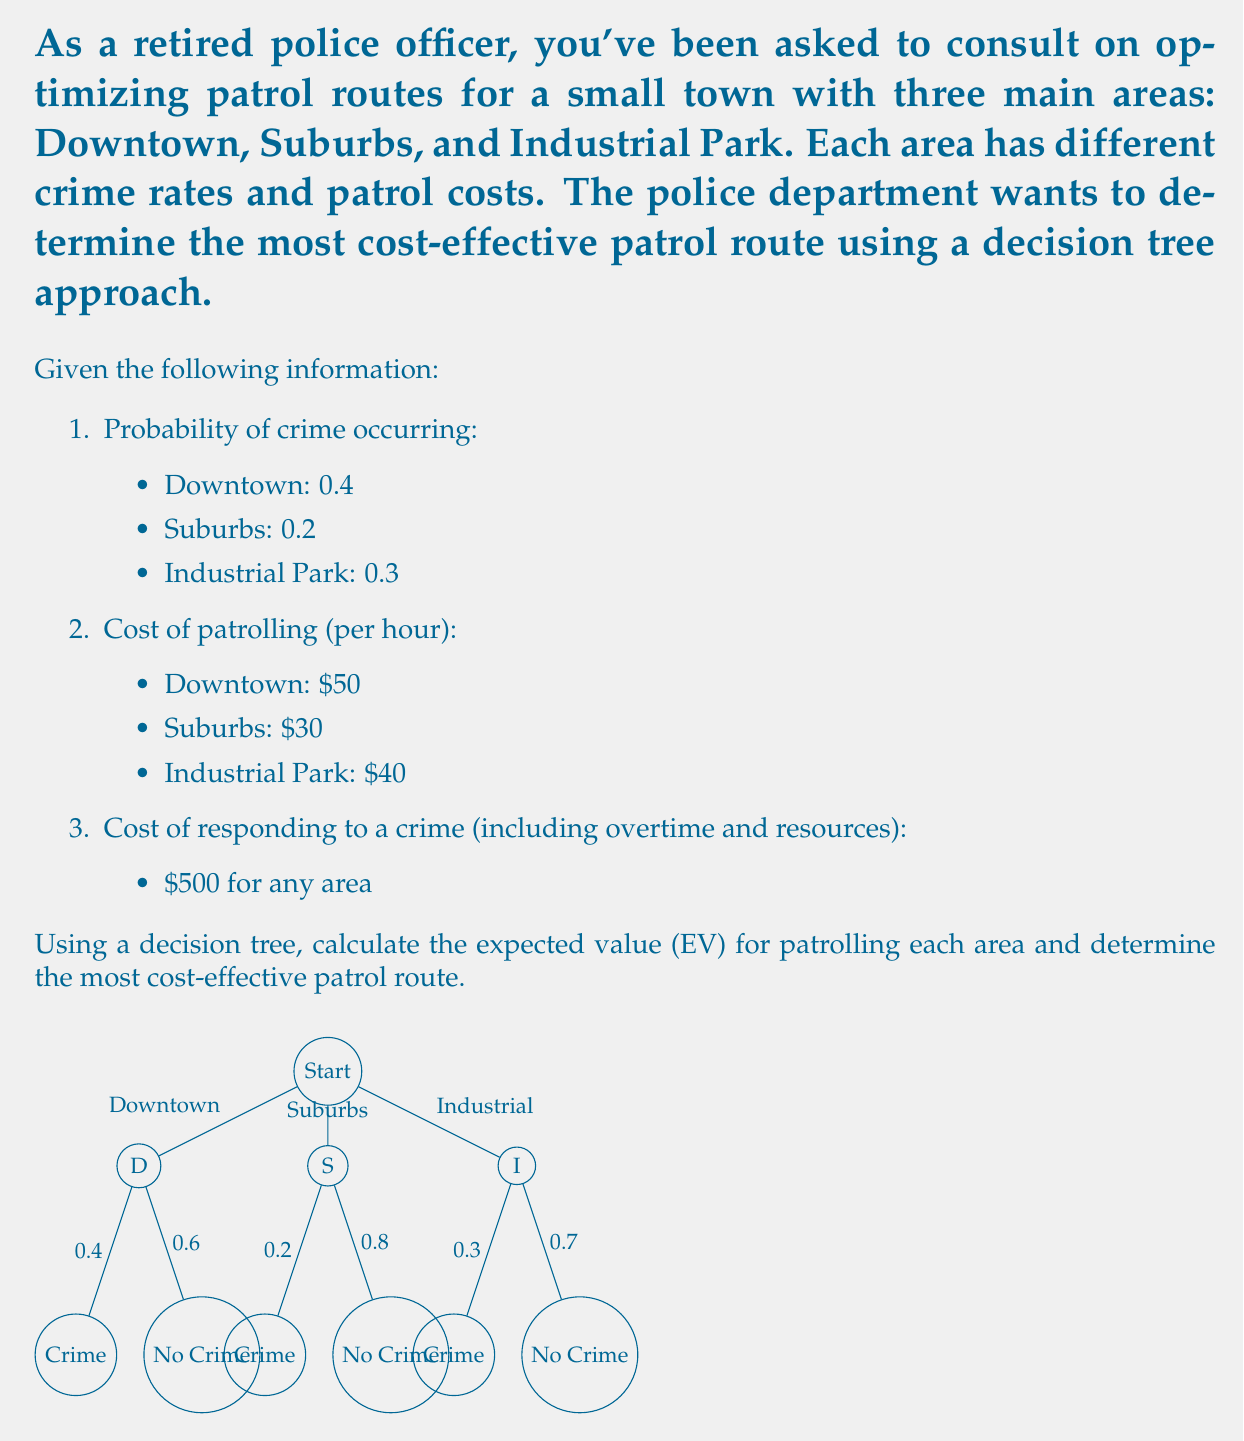Could you help me with this problem? Let's solve this problem step-by-step using decision tree analysis and expected value calculations:

1. Calculate the expected value for patrolling Downtown:
   - Probability of crime: 0.4
   - Probability of no crime: 1 - 0.4 = 0.6
   - Cost if crime occurs: $50 (patrol) + $500 (response) = $550
   - Cost if no crime occurs: $50 (patrol only)
   
   $EV_{Downtown} = 0.4 \times 550 + 0.6 \times 50 = 220 + 30 = $250$

2. Calculate the expected value for patrolling Suburbs:
   - Probability of crime: 0.2
   - Probability of no crime: 1 - 0.2 = 0.8
   - Cost if crime occurs: $30 (patrol) + $500 (response) = $530
   - Cost if no crime occurs: $30 (patrol only)
   
   $EV_{Suburbs} = 0.2 \times 530 + 0.8 \times 30 = 106 + 24 = $130$

3. Calculate the expected value for patrolling Industrial Park:
   - Probability of crime: 0.3
   - Probability of no crime: 1 - 0.3 = 0.7
   - Cost if crime occurs: $40 (patrol) + $500 (response) = $540
   - Cost if no crime occurs: $40 (patrol only)
   
   $EV_{Industrial} = 0.3 \times 540 + 0.7 \times 40 = 162 + 28 = $190$

4. Compare the expected values:
   - Downtown: $250
   - Suburbs: $130
   - Industrial Park: $190

The most cost-effective patrol route is the one with the lowest expected value, which represents the lowest expected cost.
Answer: Suburbs ($130) 